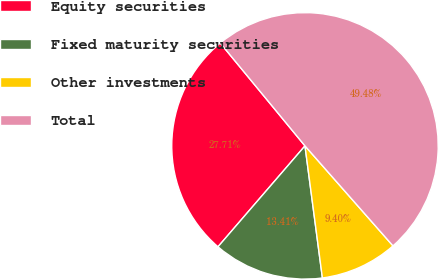Convert chart. <chart><loc_0><loc_0><loc_500><loc_500><pie_chart><fcel>Equity securities<fcel>Fixed maturity securities<fcel>Other investments<fcel>Total<nl><fcel>27.71%<fcel>13.41%<fcel>9.4%<fcel>49.48%<nl></chart> 